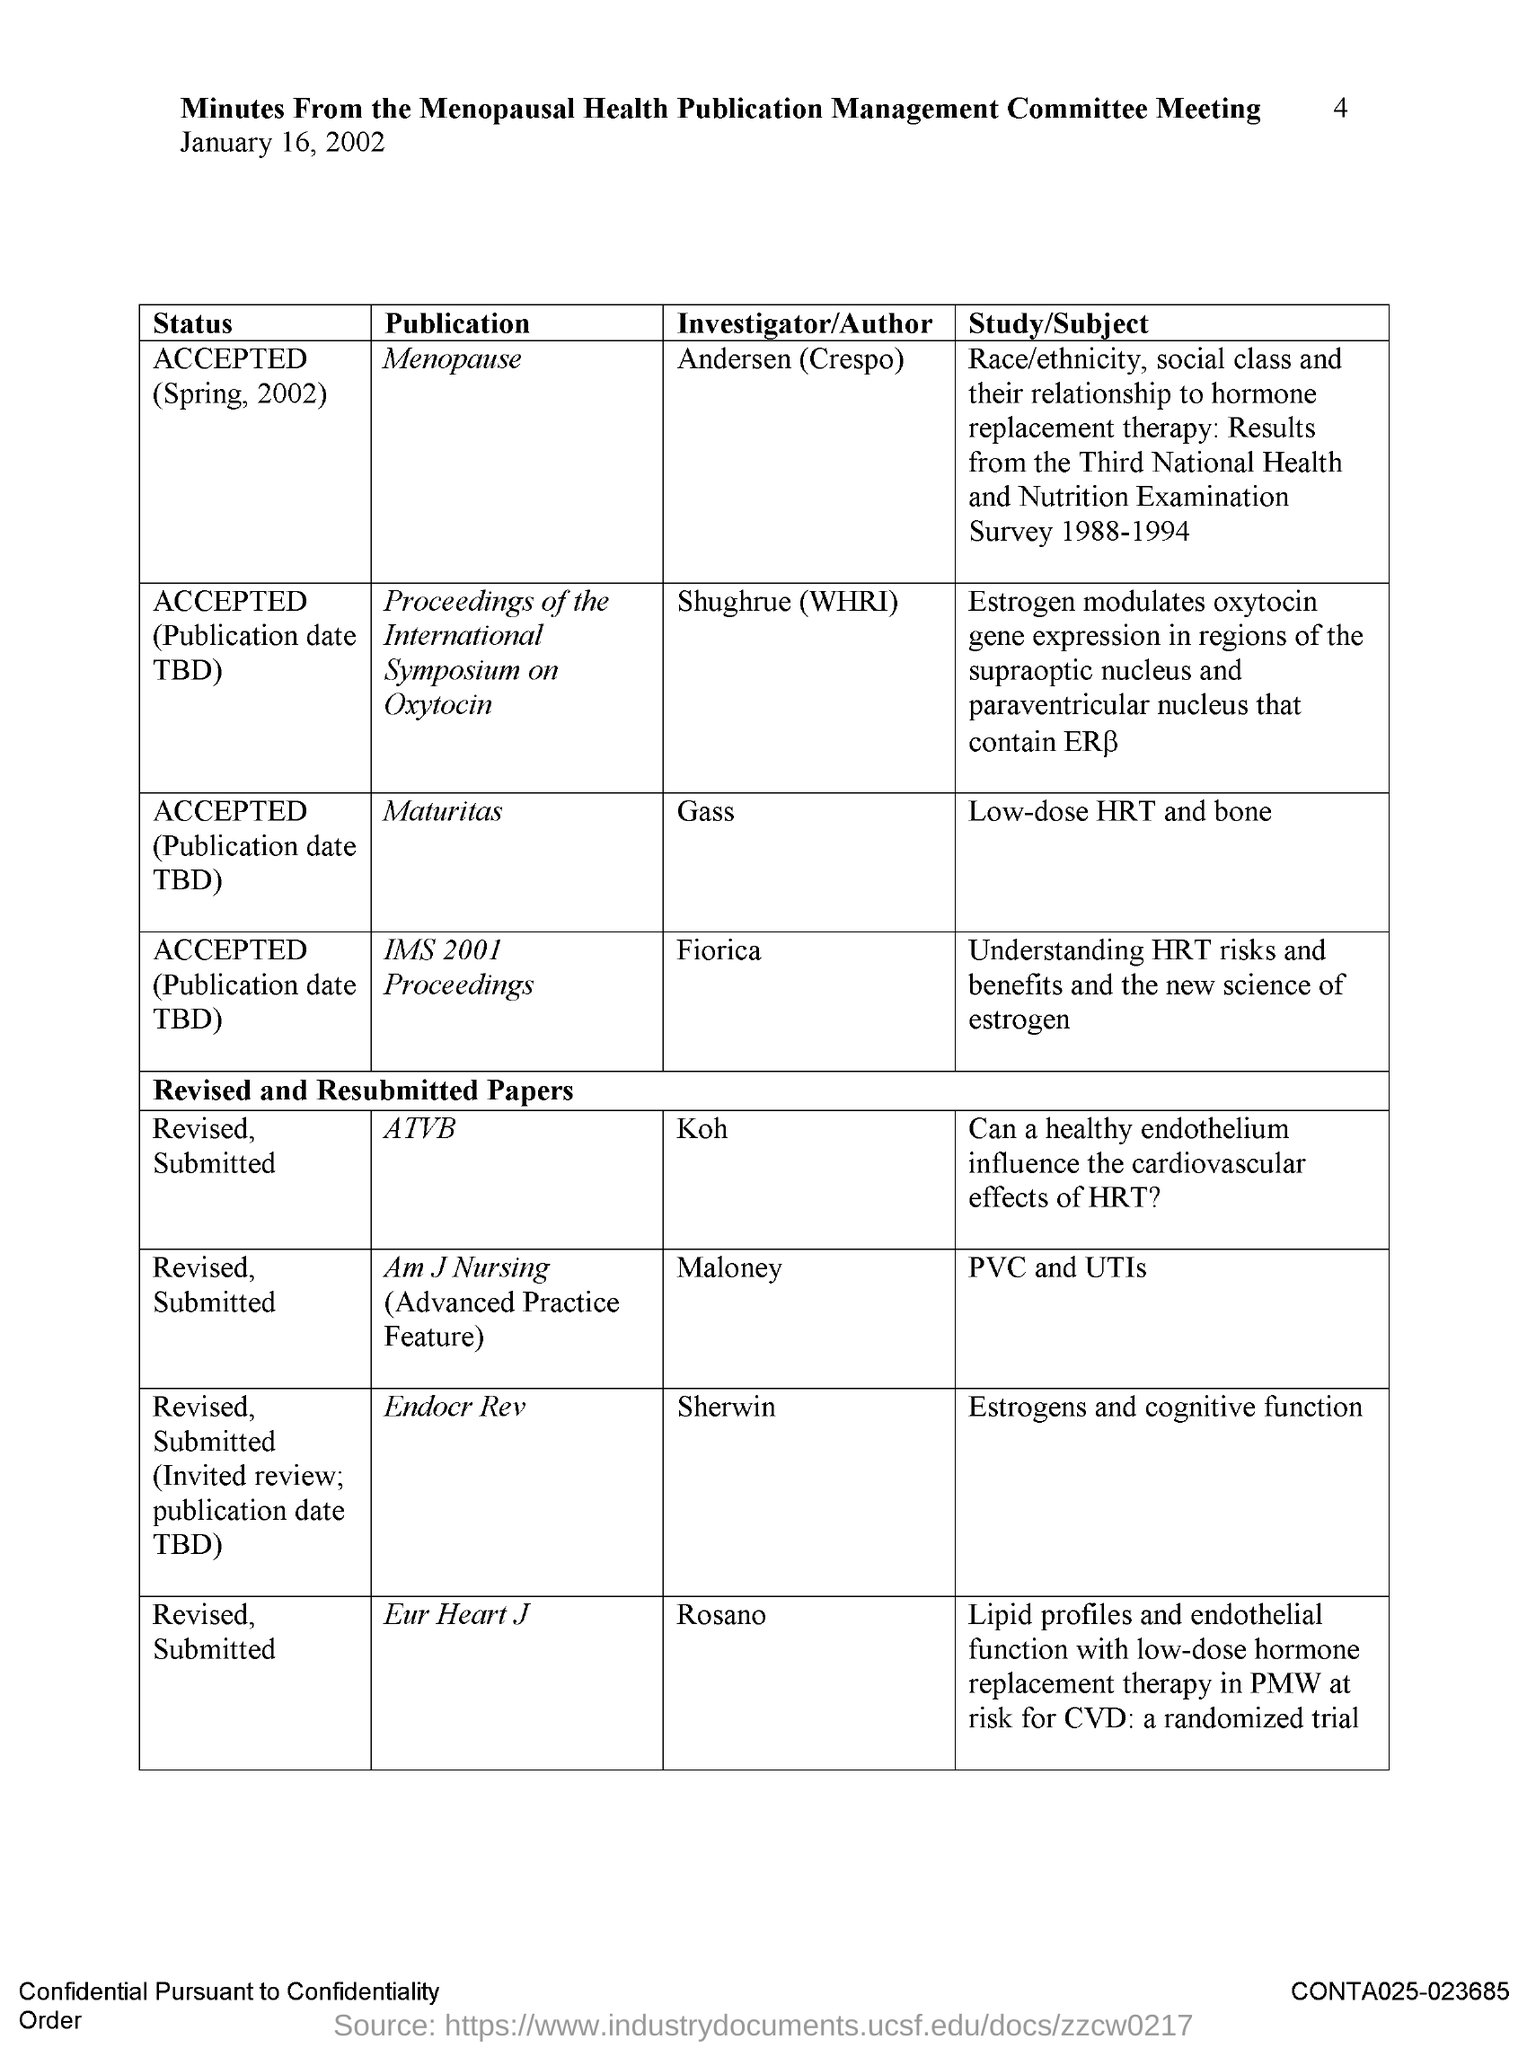Outline some significant characteristics in this image. The author of the publication "Maturitas" is Gass. Sherwin is the author of the publication "Endocr Rev. Koh is the author of the publication "ATVB." The page number is 4, as declared. The date mentioned in the document is January 16, 2002. 